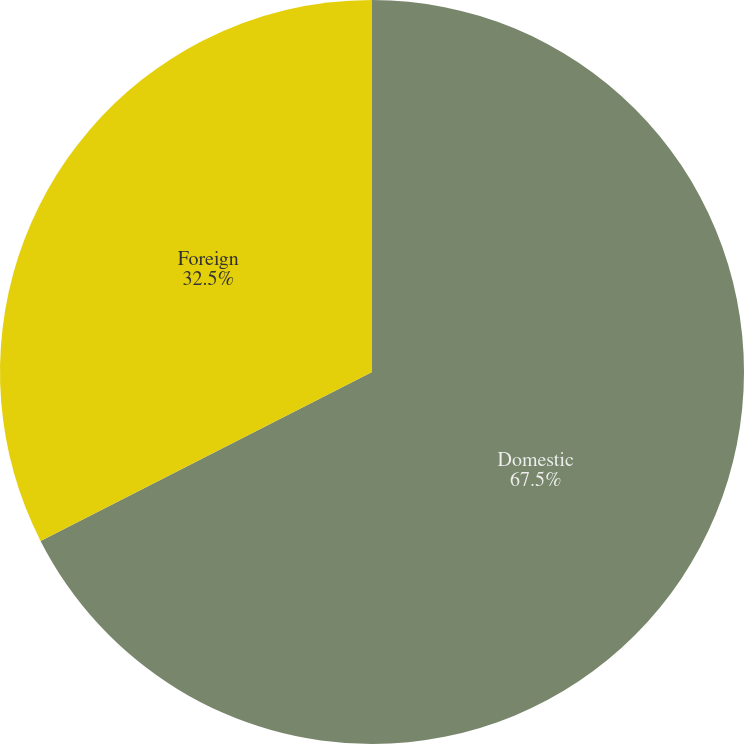<chart> <loc_0><loc_0><loc_500><loc_500><pie_chart><fcel>Domestic<fcel>Foreign<nl><fcel>67.5%<fcel>32.5%<nl></chart> 